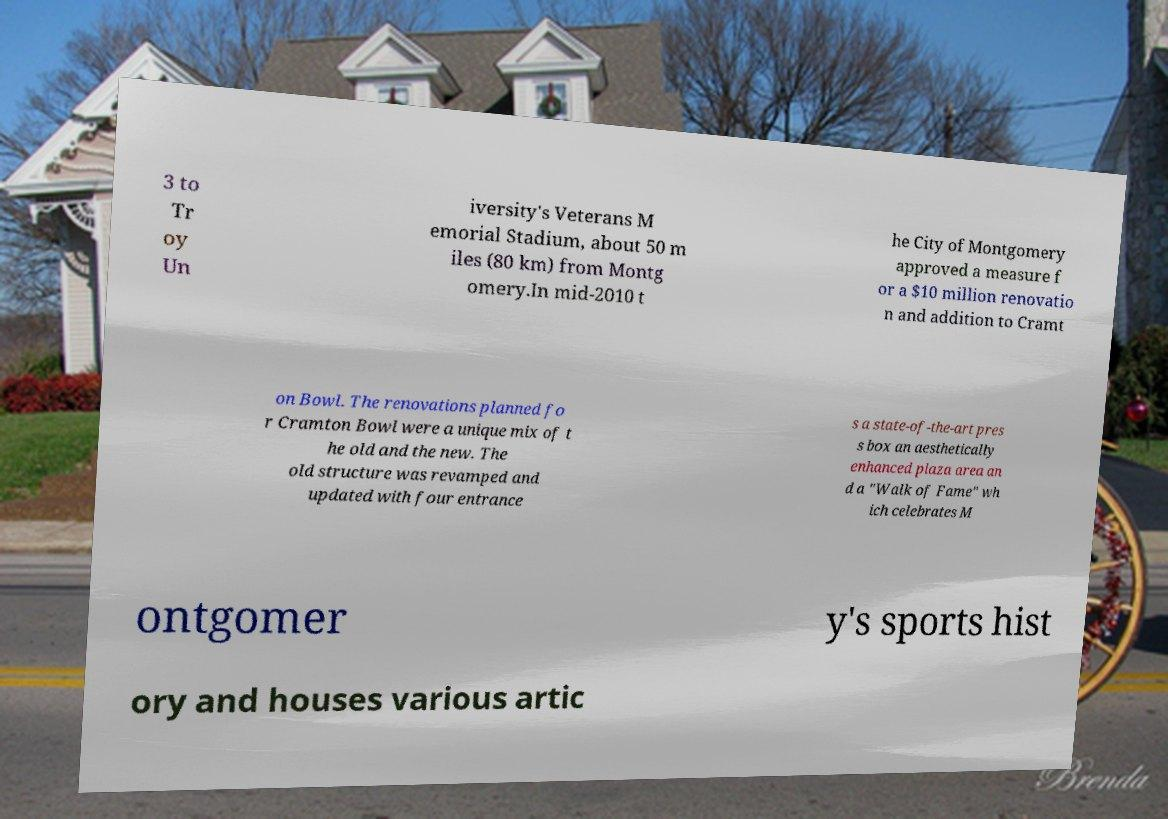For documentation purposes, I need the text within this image transcribed. Could you provide that? 3 to Tr oy Un iversity's Veterans M emorial Stadium, about 50 m iles (80 km) from Montg omery.In mid-2010 t he City of Montgomery approved a measure f or a $10 million renovatio n and addition to Cramt on Bowl. The renovations planned fo r Cramton Bowl were a unique mix of t he old and the new. The old structure was revamped and updated with four entrance s a state-of-the-art pres s box an aesthetically enhanced plaza area an d a "Walk of Fame" wh ich celebrates M ontgomer y's sports hist ory and houses various artic 